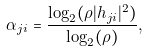<formula> <loc_0><loc_0><loc_500><loc_500>\alpha _ { j i } = \frac { \log _ { 2 } ( \rho | h _ { j i } | ^ { 2 } ) } { \log _ { 2 } ( \rho ) } ,</formula> 